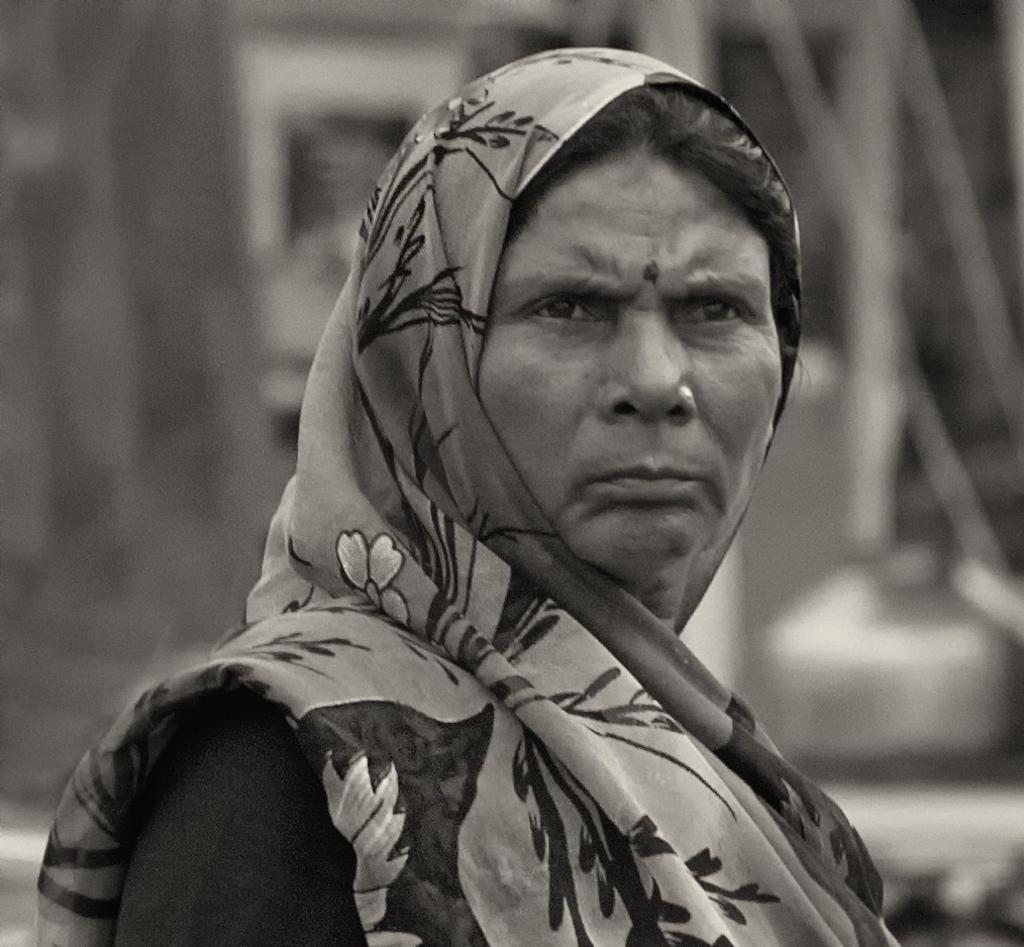Could you give a brief overview of what you see in this image? This is a black and white image. In the center of the image there is a lady wearing a saree. 